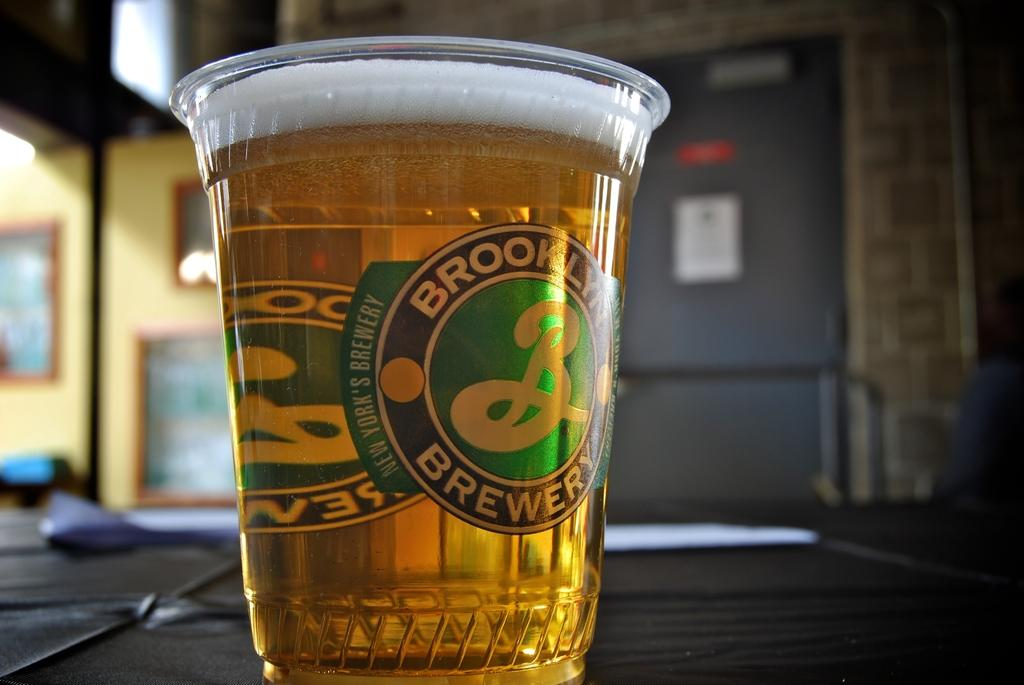<image>
Summarize the visual content of the image. A plastic Brooklyn Brewery cup filled with beer 